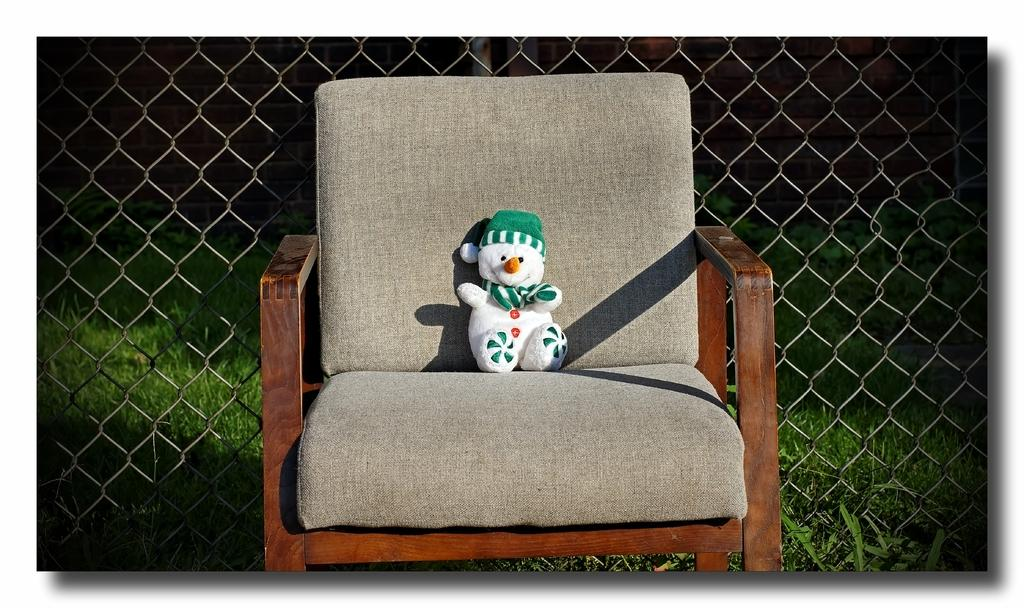What object is in the image that people can sit on? There is a chair in the image. What is on the chair? There is a doll on the chair. What colors can be seen on the doll? The doll has white, green, and orange colors. What can be seen in the background of the image? There is a metal mesh and grass in the background of the image. Can you tell me how many pears are on the doll's head in the image? There are no pears present in the image, and the doll's head is not mentioned in the provided facts. 